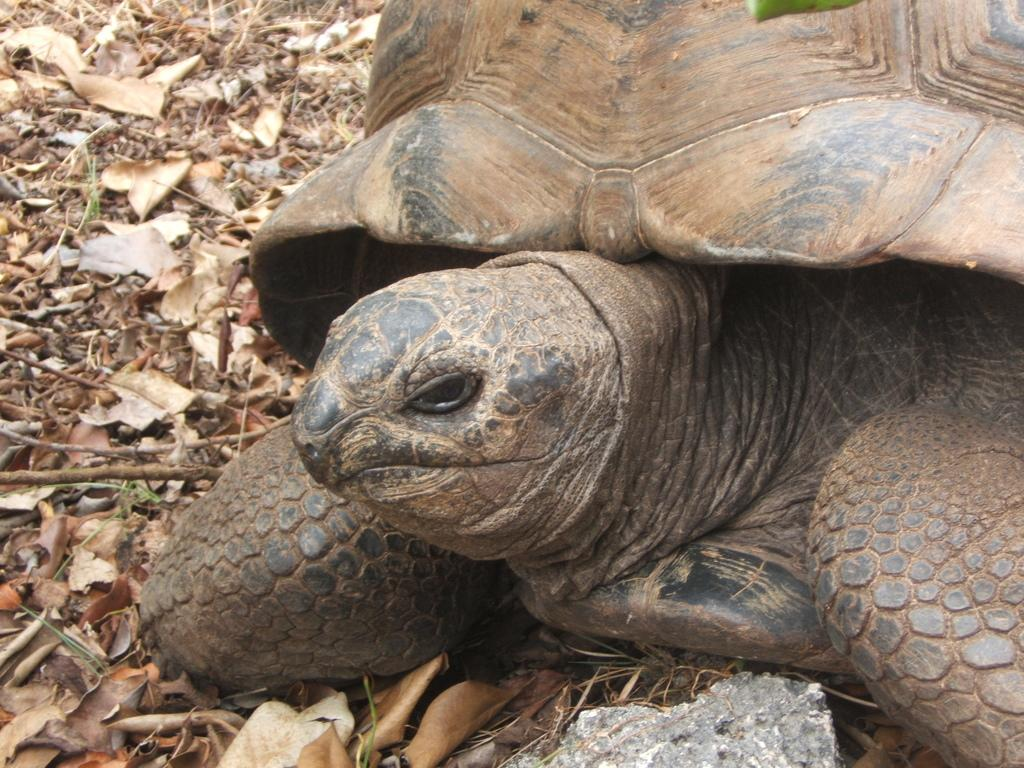What type of animal is in the image? There is a tortoise in the image. What can be seen on the ground in the image? There are stones and leaves on the ground in the image. What type of seed is the tortoise planting in the image? There is no seed present in the image, nor is the tortoise shown planting anything. 